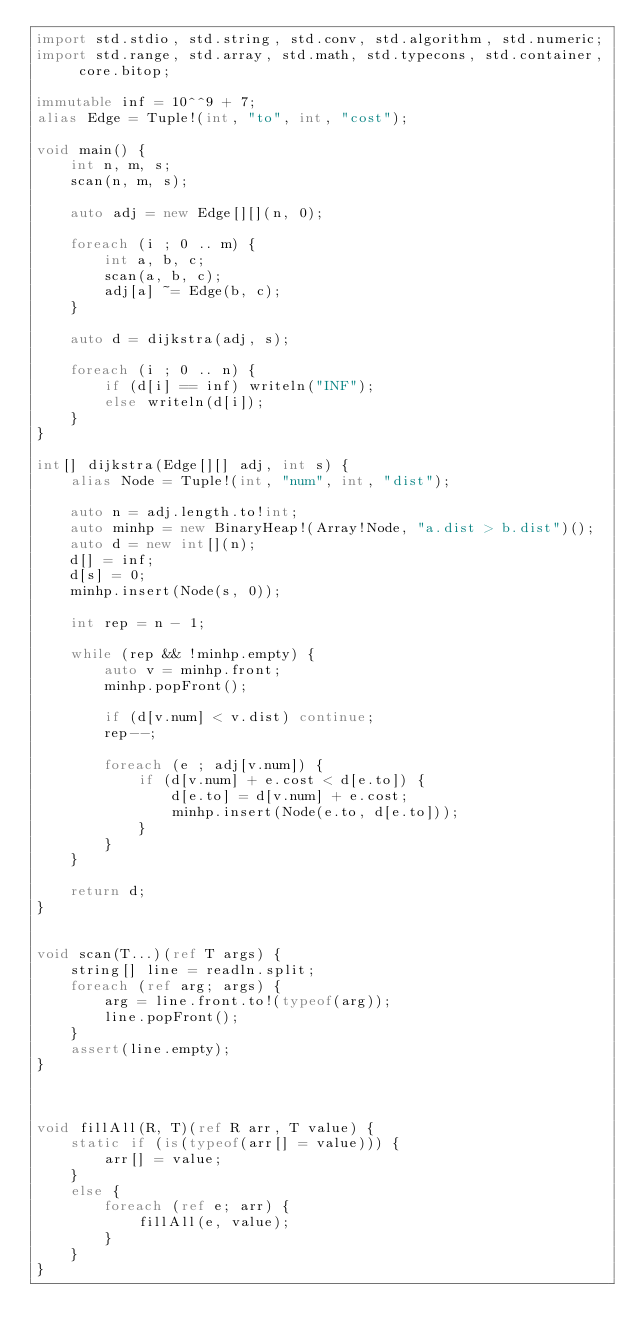<code> <loc_0><loc_0><loc_500><loc_500><_D_>import std.stdio, std.string, std.conv, std.algorithm, std.numeric;
import std.range, std.array, std.math, std.typecons, std.container, core.bitop;

immutable inf = 10^^9 + 7;
alias Edge = Tuple!(int, "to", int, "cost");

void main() {
    int n, m, s;
    scan(n, m, s);

    auto adj = new Edge[][](n, 0);

    foreach (i ; 0 .. m) {
        int a, b, c;
        scan(a, b, c);
        adj[a] ~= Edge(b, c);
    }

    auto d = dijkstra(adj, s);

    foreach (i ; 0 .. n) {
        if (d[i] == inf) writeln("INF");
        else writeln(d[i]);
    }
}

int[] dijkstra(Edge[][] adj, int s) {
    alias Node = Tuple!(int, "num", int, "dist");

    auto n = adj.length.to!int;
    auto minhp = new BinaryHeap!(Array!Node, "a.dist > b.dist")();
    auto d = new int[](n);
    d[] = inf;
    d[s] = 0;
    minhp.insert(Node(s, 0));

    int rep = n - 1;

    while (rep && !minhp.empty) {
        auto v = minhp.front;
        minhp.popFront();

        if (d[v.num] < v.dist) continue;
        rep--;

        foreach (e ; adj[v.num]) {
            if (d[v.num] + e.cost < d[e.to]) {
                d[e.to] = d[v.num] + e.cost;
                minhp.insert(Node(e.to, d[e.to]));
            }
        }
    }

    return d;
}


void scan(T...)(ref T args) {
    string[] line = readln.split;
    foreach (ref arg; args) {
        arg = line.front.to!(typeof(arg));
        line.popFront();
    }
    assert(line.empty);
}



void fillAll(R, T)(ref R arr, T value) {
    static if (is(typeof(arr[] = value))) {
        arr[] = value;
    }
    else {
        foreach (ref e; arr) {
            fillAll(e, value);
        }
    }
}</code> 